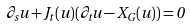Convert formula to latex. <formula><loc_0><loc_0><loc_500><loc_500>\partial _ { s } u + J _ { t } ( u ) ( \partial _ { t } u - X _ { G } ( u ) ) = 0</formula> 